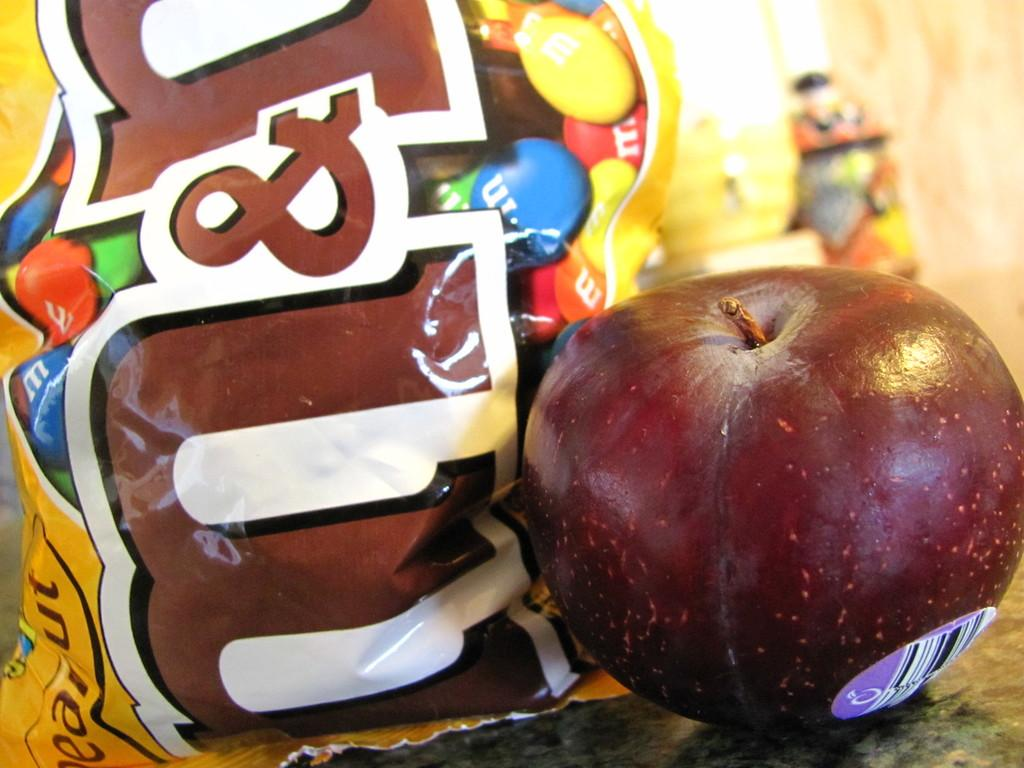What type of fruit is in the image? There is an apple in the image. What type of sweet treat is in the image? There is a candies packet in the image. Where are the apple and the candies packet located in the image? Both the apple and the candies packet are on the floor. What type of cracker is being used as a swing in the image? There is no cracker or swing present in the image. 